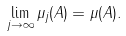<formula> <loc_0><loc_0><loc_500><loc_500>\lim _ { j \to \infty } \mu _ { j } ( A ) = \mu ( A ) .</formula> 